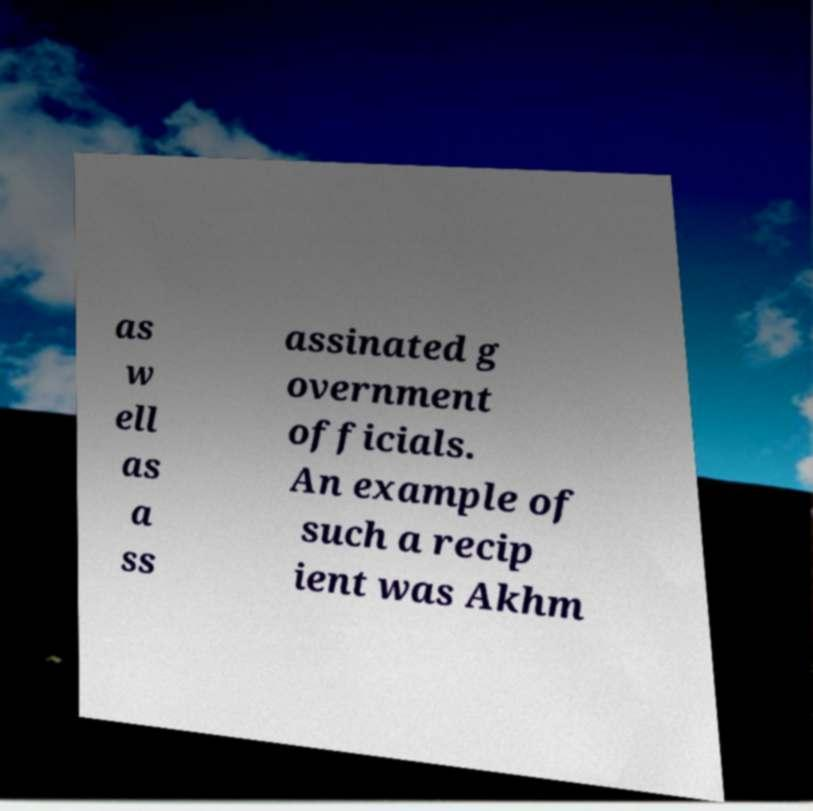There's text embedded in this image that I need extracted. Can you transcribe it verbatim? as w ell as a ss assinated g overnment officials. An example of such a recip ient was Akhm 